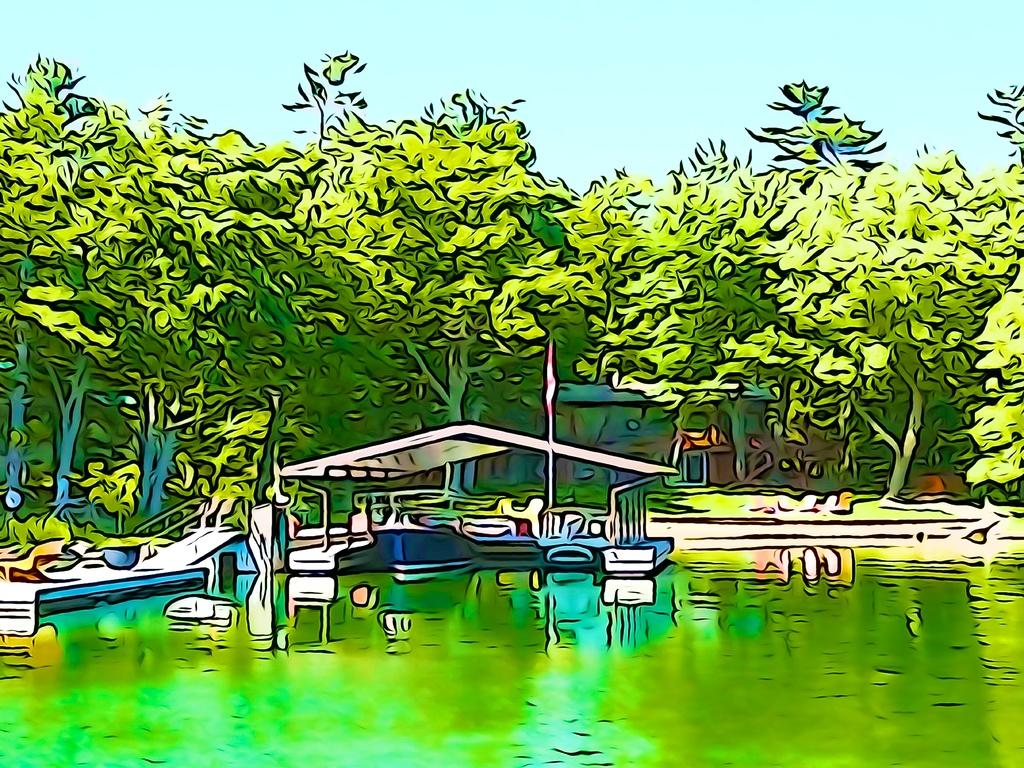What type of image is being presented? The image is an edited picture. What natural elements can be seen in the image? There are trees and water visible in the image. What type of structure is present in the image? There is a shed in the image. What part of the natural environment is visible in the image? The sky is visible in the image. What suggestions does the government have for improving the shed in the image? The image does not contain any information about the government or their suggestions for improving the shed. 